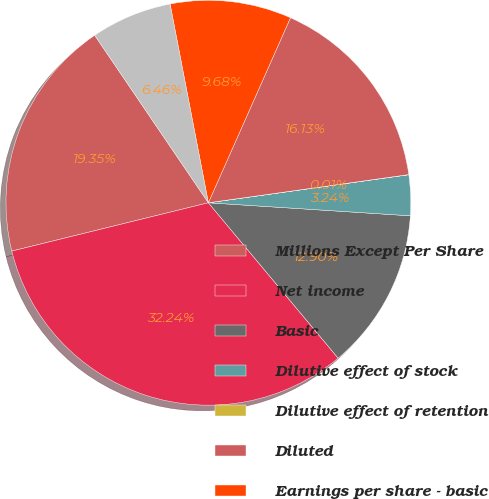<chart> <loc_0><loc_0><loc_500><loc_500><pie_chart><fcel>Millions Except Per Share<fcel>Net income<fcel>Basic<fcel>Dilutive effect of stock<fcel>Dilutive effect of retention<fcel>Diluted<fcel>Earnings per share - basic<fcel>Earnings per share - diluted<nl><fcel>19.35%<fcel>32.24%<fcel>12.9%<fcel>3.24%<fcel>0.01%<fcel>16.13%<fcel>9.68%<fcel>6.46%<nl></chart> 